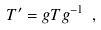Convert formula to latex. <formula><loc_0><loc_0><loc_500><loc_500>T ^ { \prime } = g T g ^ { - 1 } \ ,</formula> 